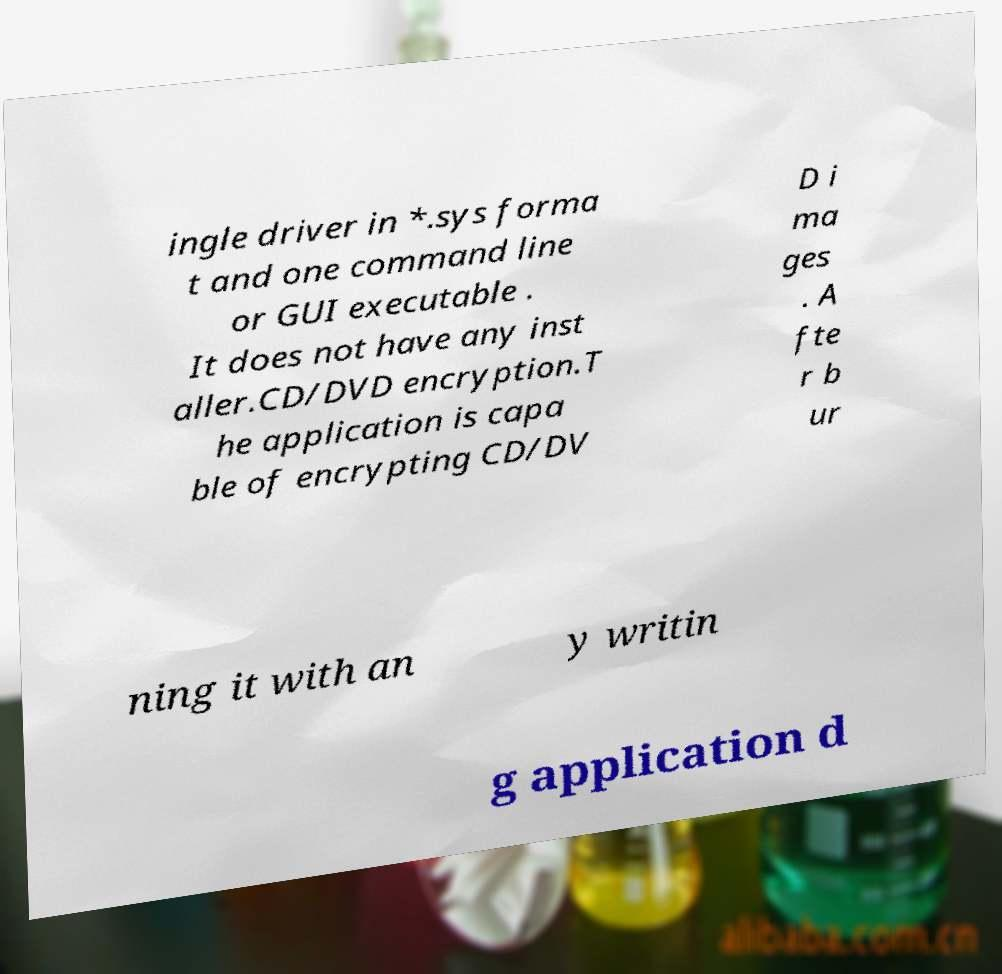Please read and relay the text visible in this image. What does it say? ingle driver in *.sys forma t and one command line or GUI executable . It does not have any inst aller.CD/DVD encryption.T he application is capa ble of encrypting CD/DV D i ma ges . A fte r b ur ning it with an y writin g application d 